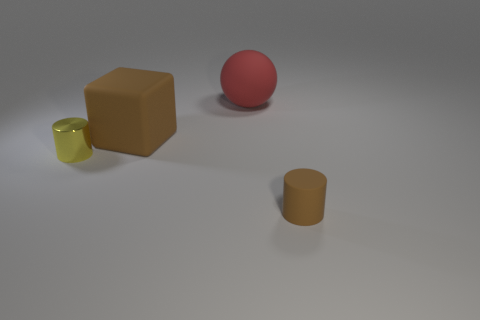The tiny cylinder that is the same material as the large brown block is what color?
Keep it short and to the point. Brown. Is the size of the red ball the same as the brown object in front of the brown cube?
Ensure brevity in your answer.  No. The big red object has what shape?
Make the answer very short. Sphere. How many other balls have the same color as the rubber sphere?
Your answer should be compact. 0. The other thing that is the same shape as the small shiny thing is what color?
Provide a short and direct response. Brown. There is a cylinder on the right side of the small yellow cylinder; what number of rubber cubes are in front of it?
Provide a short and direct response. 0. How many cubes are either tiny yellow metal objects or large rubber things?
Offer a terse response. 1. Is there a small thing?
Provide a short and direct response. Yes. What size is the yellow shiny thing that is the same shape as the tiny brown object?
Provide a short and direct response. Small. What is the shape of the small yellow shiny object behind the small thing to the right of the small yellow shiny thing?
Provide a succinct answer. Cylinder. 